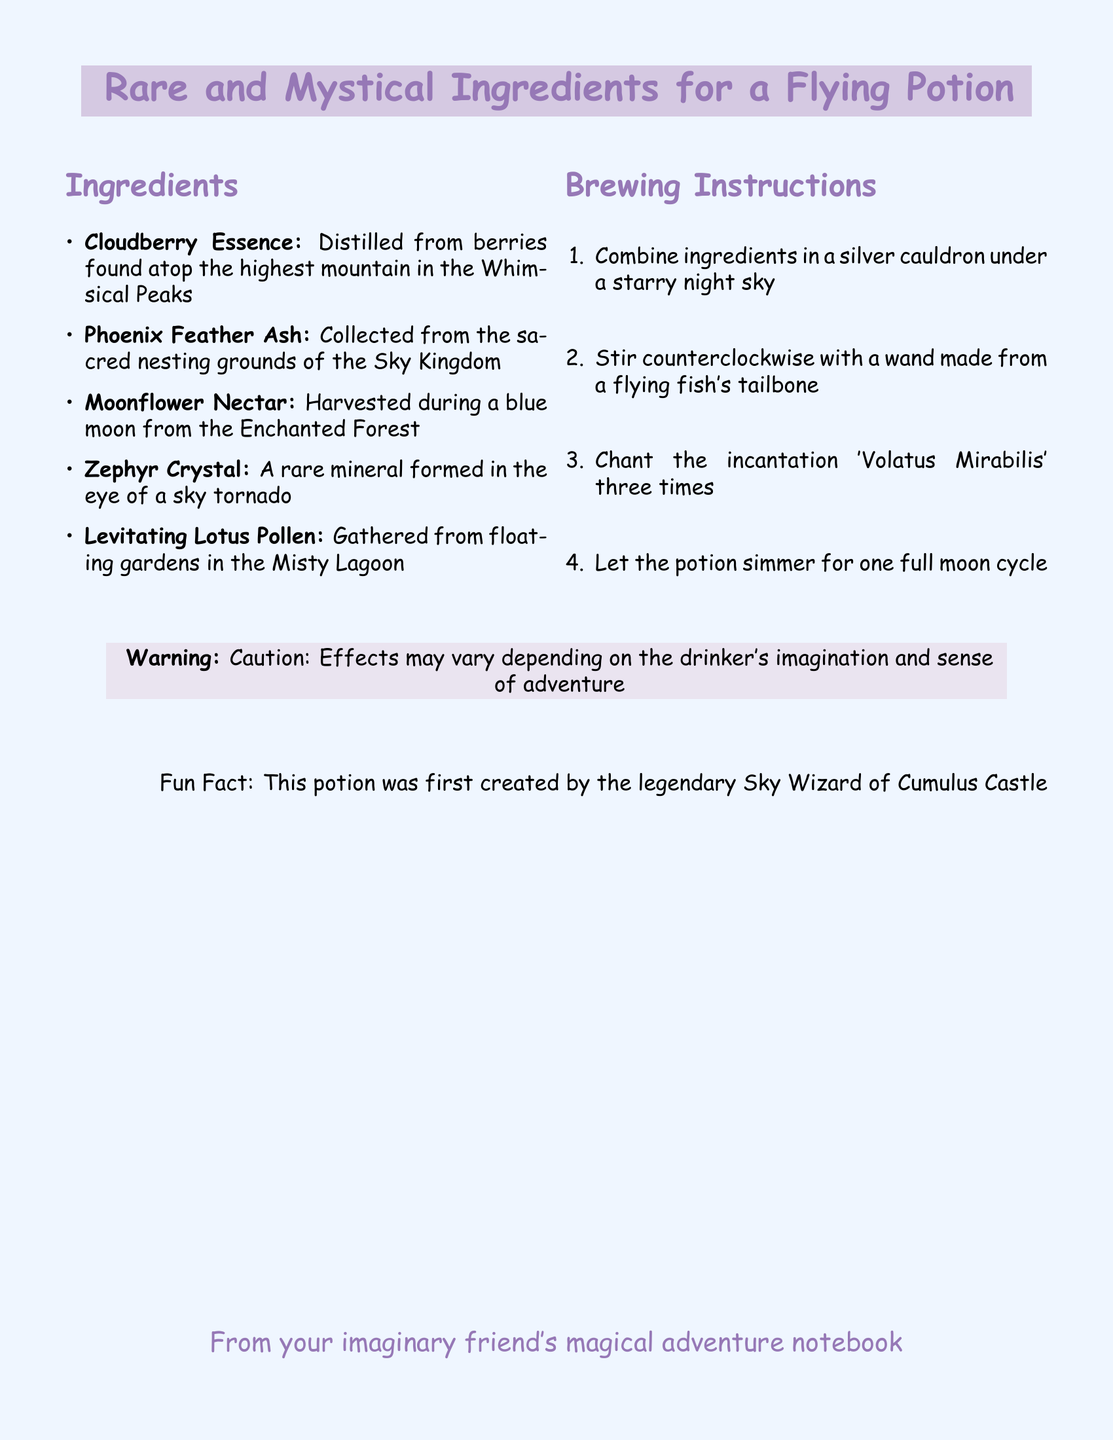What is the first ingredient listed for the potion? The first ingredient mentioned in the document is Cloudberry Essence.
Answer: Cloudberry Essence How many ingredients are needed to brew the potion? The document lists a total of five ingredients required to brew the potion.
Answer: Five What must be done under a starry night sky? The ingredients must be combined in a silver cauldron under a starry night sky.
Answer: Combine ingredients What is the incantation that needs to be chanted? The incantation to be chanted is 'Volatus Mirabilis'.
Answer: Volatus Mirabilis What is the fun fact mentioned in the document? The fun fact states that the potion was first created by the legendary Sky Wizard of Cumulus Castle.
Answer: Legendary Sky Wizard of Cumulus Castle How long should the potion simmer? The potion should simmer for one full moon cycle.
Answer: One full moon cycle Where is the Phoenix Feather Ash collected from? The Phoenix Feather Ash is collected from the sacred nesting grounds of the Sky Kingdom.
Answer: Sacred nesting grounds of the Sky Kingdom What is the color of the background in the document? The background color of the document is light blue, referred to as cloudblue.
Answer: Cloudblue 